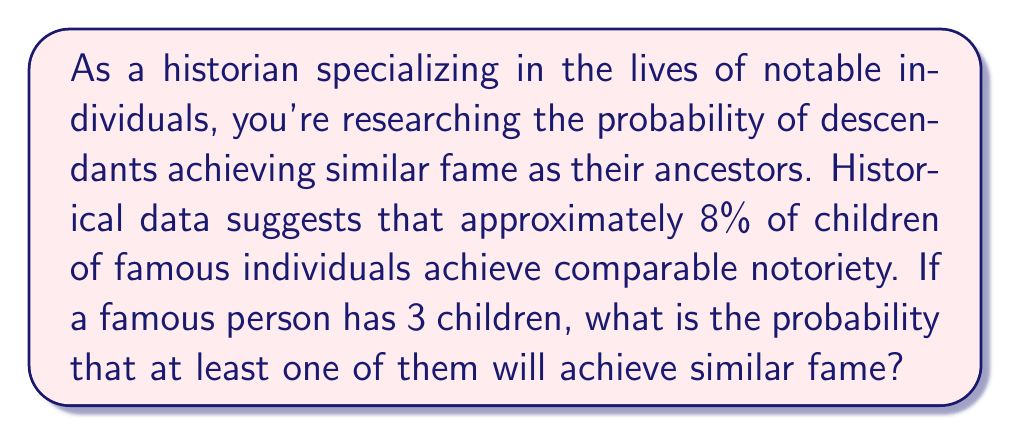Solve this math problem. To solve this problem, we can use the complement rule of probability. Instead of calculating the probability of at least one child achieving fame directly, we'll calculate the probability of no children achieving fame and subtract it from 1.

Let's break it down step-by-step:

1. Probability of a child achieving fame: $p = 0.08$ (8%)
2. Probability of a child not achieving fame: $1 - p = 1 - 0.08 = 0.92$ (92%)
3. Number of children: $n = 3$

The probability of none of the three children achieving fame is:

$$ P(\text{no famous children}) = (0.92)^3 $$

Now, we can calculate the probability of at least one child achieving fame:

$$ \begin{align*}
P(\text{at least one famous child}) &= 1 - P(\text{no famous children}) \\
&= 1 - (0.92)^3 \\
&= 1 - 0.778688 \\
&\approx 0.221312
\end{align*} $$

This can be expressed as a percentage:

$$ 0.221312 \times 100\% \approx 22.13\% $$
Answer: The probability that at least one of the famous person's three children will achieve similar fame is approximately 22.13%. 